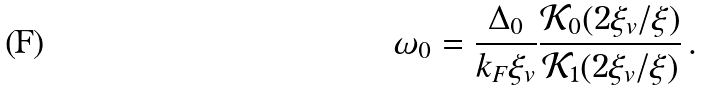<formula> <loc_0><loc_0><loc_500><loc_500>\omega _ { 0 } = \frac { \Delta _ { 0 } } { k _ { F } \xi _ { v } } \frac { \mathcal { K } _ { 0 } ( 2 \xi _ { v } / \xi ) } { \mathcal { K } _ { 1 } ( 2 \xi _ { v } / \xi ) } \, .</formula> 